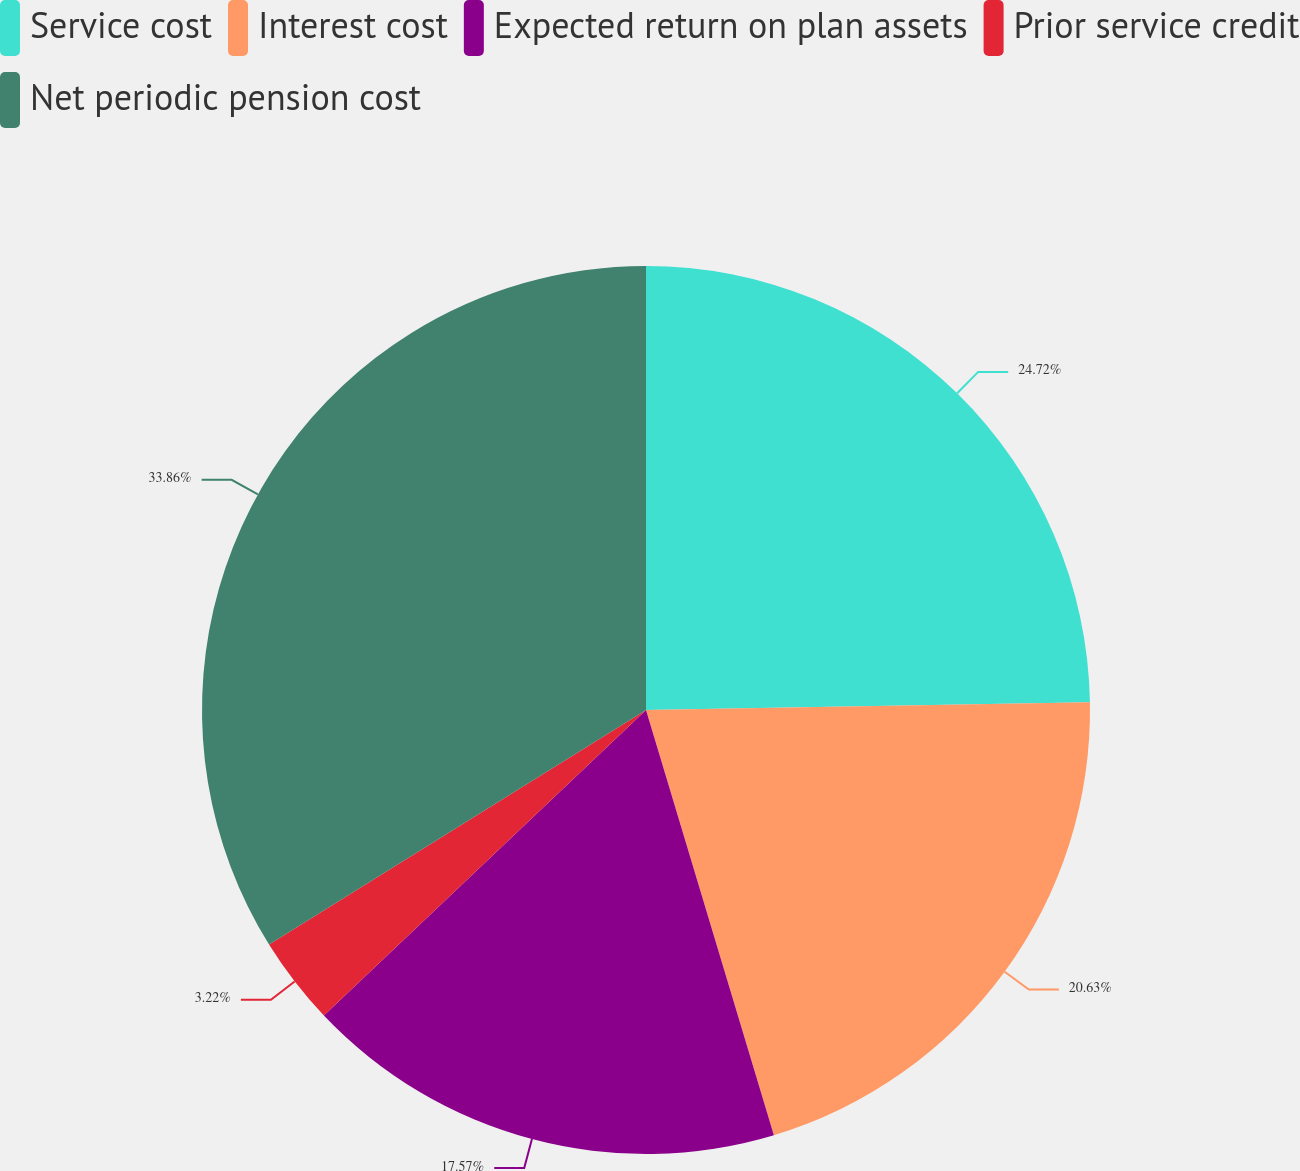<chart> <loc_0><loc_0><loc_500><loc_500><pie_chart><fcel>Service cost<fcel>Interest cost<fcel>Expected return on plan assets<fcel>Prior service credit<fcel>Net periodic pension cost<nl><fcel>24.72%<fcel>20.63%<fcel>17.57%<fcel>3.22%<fcel>33.86%<nl></chart> 